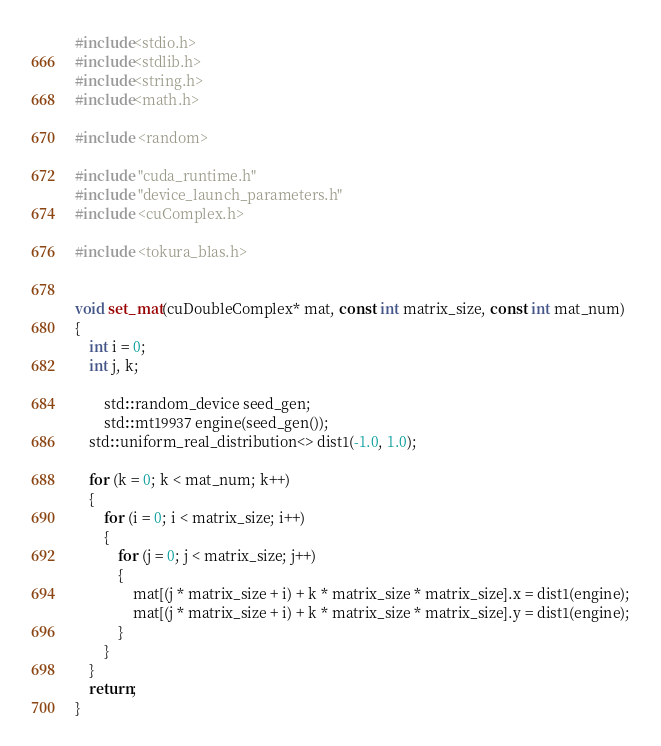<code> <loc_0><loc_0><loc_500><loc_500><_Cuda_>#include<stdio.h>
#include<stdlib.h>
#include<string.h>
#include<math.h>

#include <random>

#include "cuda_runtime.h"
#include "device_launch_parameters.h"
#include <cuComplex.h>

#include <tokura_blas.h>


void set_mat(cuDoubleComplex* mat, const int matrix_size, const int mat_num)
{
	int i = 0;
	int j, k;

        std::random_device seed_gen;
        std::mt19937 engine(seed_gen());
	std::uniform_real_distribution<> dist1(-1.0, 1.0);

	for (k = 0; k < mat_num; k++)
	{
		for (i = 0; i < matrix_size; i++)
		{
			for (j = 0; j < matrix_size; j++)
			{
				mat[(j * matrix_size + i) + k * matrix_size * matrix_size].x = dist1(engine);
				mat[(j * matrix_size + i) + k * matrix_size * matrix_size].y = dist1(engine);
			}
		}
	}
	return;
}
</code> 